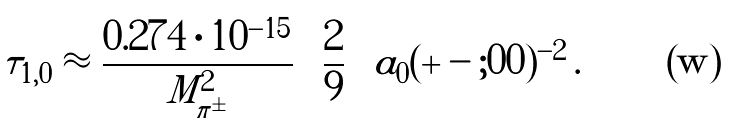<formula> <loc_0><loc_0><loc_500><loc_500>\tau _ { 1 , 0 } \approx \frac { 0 . 2 7 4 \cdot 1 0 ^ { - 1 5 } } { M _ { \pi ^ { \pm } } ^ { 2 } } \left ( \frac { 2 } { 9 } \right ) a _ { 0 } ( + - ; 0 0 ) ^ { - 2 } \, .</formula> 